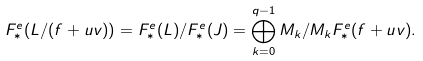Convert formula to latex. <formula><loc_0><loc_0><loc_500><loc_500>F _ { * } ^ { e } ( L / ( f + u v ) ) = F _ { * } ^ { e } ( L ) / F _ { * } ^ { e } ( J ) = \bigoplus _ { k = 0 } ^ { q - 1 } M _ { k } / M _ { k } F _ { * } ^ { e } ( f + u v ) .</formula> 